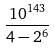<formula> <loc_0><loc_0><loc_500><loc_500>\frac { 1 0 ^ { 1 4 3 } } { 4 - 2 ^ { 6 } }</formula> 